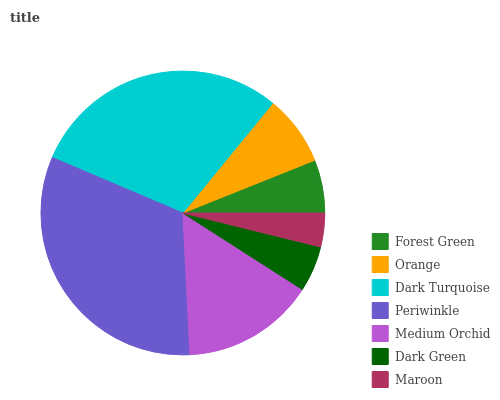Is Maroon the minimum?
Answer yes or no. Yes. Is Periwinkle the maximum?
Answer yes or no. Yes. Is Orange the minimum?
Answer yes or no. No. Is Orange the maximum?
Answer yes or no. No. Is Orange greater than Forest Green?
Answer yes or no. Yes. Is Forest Green less than Orange?
Answer yes or no. Yes. Is Forest Green greater than Orange?
Answer yes or no. No. Is Orange less than Forest Green?
Answer yes or no. No. Is Orange the high median?
Answer yes or no. Yes. Is Orange the low median?
Answer yes or no. Yes. Is Dark Turquoise the high median?
Answer yes or no. No. Is Dark Turquoise the low median?
Answer yes or no. No. 